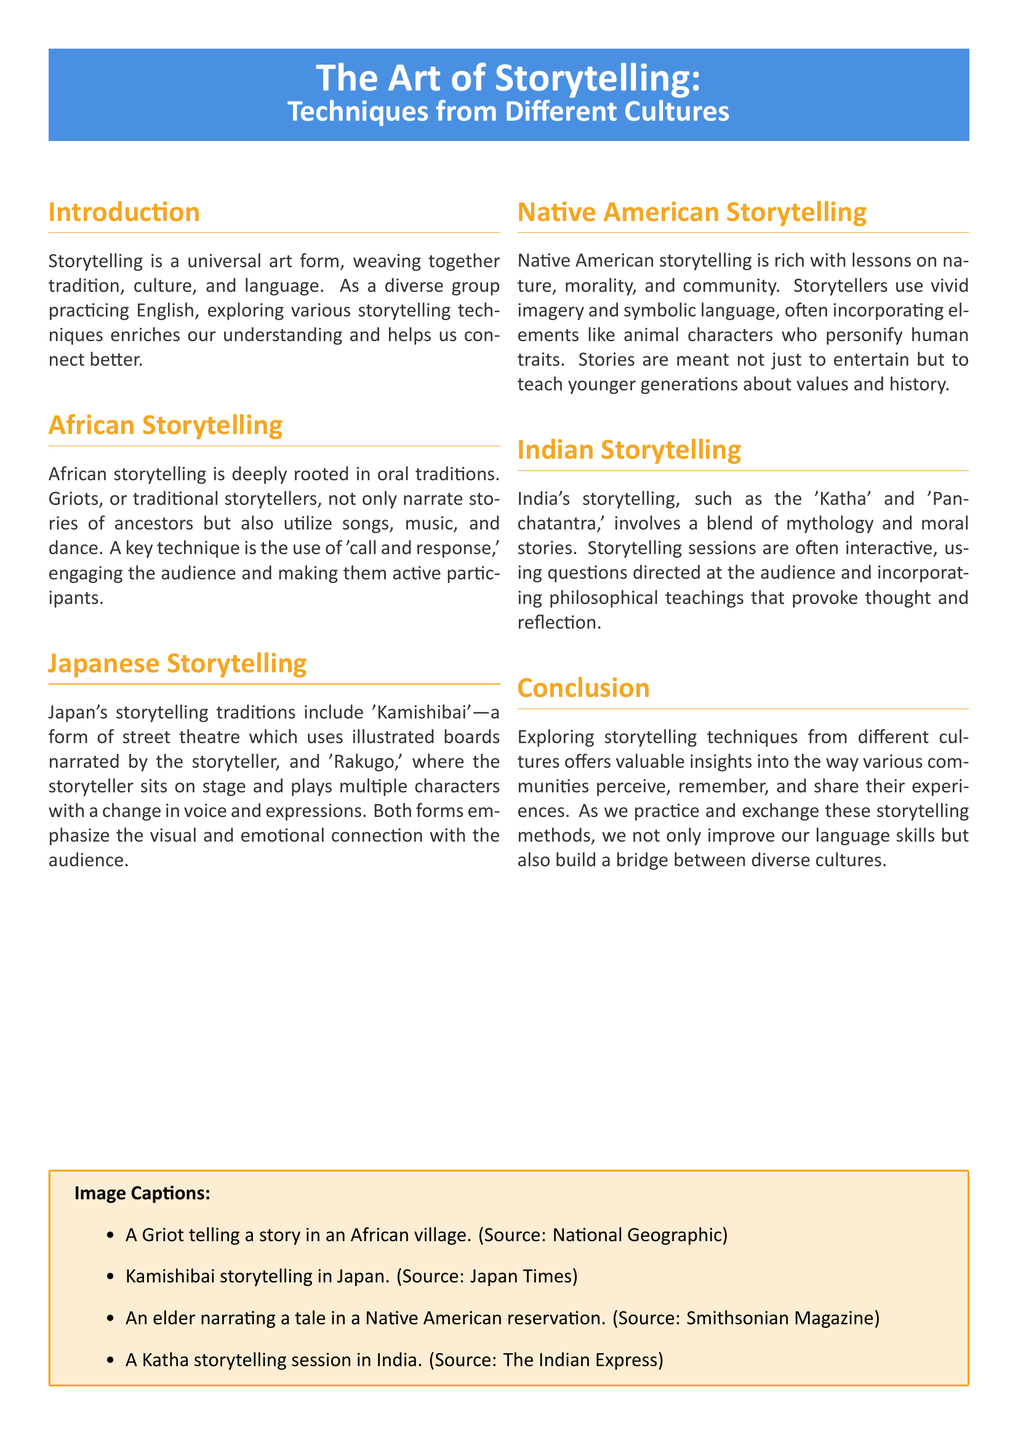What is the title of the document? The title is prominently displayed at the beginning of the document.
Answer: The Art of Storytelling: Techniques from Different Cultures Who are the traditional storytellers in African storytelling? The document mentions a specific term for traditional storytellers in Africa.
Answer: Griots What storytelling technique is used in African storytelling to engage the audience? The document highlights a method that involves audience participation during storytelling.
Answer: Call and response What is the Japanese form of street theatre mentioned in the document? The document references a specific form of storytelling performed with illustrated boards.
Answer: Kamishibai Which storytelling tradition involves animal characters personifying human traits? The document describes a cultural approach that includes this type of character representation.
Answer: Native American Storytelling What moral stories are mentioned as part of India's storytelling tradition? The document specifies styles of storytelling that include moral lessons.
Answer: Katha and Panchatantra Which culture emphasizes visual and emotional connections in storytelling? The document discusses a country with specific storytelling practices focused on audience connection.
Answer: Japan What elements do Native American stories often incorporate? The document refers to a type of imagery and character used in Native American storytelling.
Answer: Symbolic language What is the purpose of storytelling in Native American culture, as stated in the document? The document notes a broader goal for storytelling beyond entertainment.
Answer: Teach values and history 